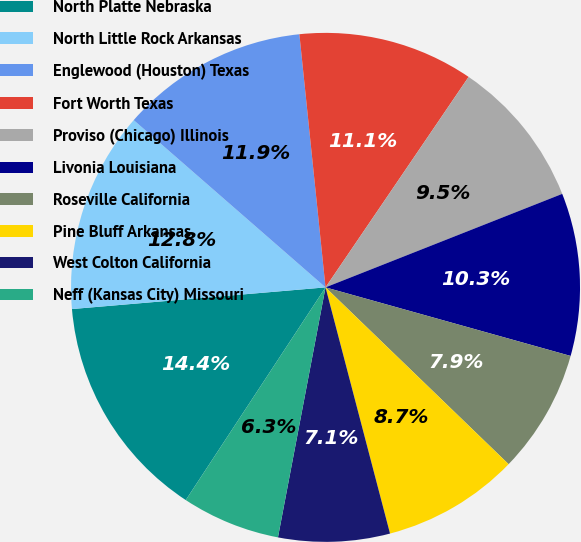<chart> <loc_0><loc_0><loc_500><loc_500><pie_chart><fcel>North Platte Nebraska<fcel>North Little Rock Arkansas<fcel>Englewood (Houston) Texas<fcel>Fort Worth Texas<fcel>Proviso (Chicago) Illinois<fcel>Livonia Louisiana<fcel>Roseville California<fcel>Pine Bluff Arkansas<fcel>West Colton California<fcel>Neff (Kansas City) Missouri<nl><fcel>14.39%<fcel>12.77%<fcel>11.95%<fcel>11.14%<fcel>9.51%<fcel>10.33%<fcel>7.88%<fcel>8.7%<fcel>7.07%<fcel>6.26%<nl></chart> 